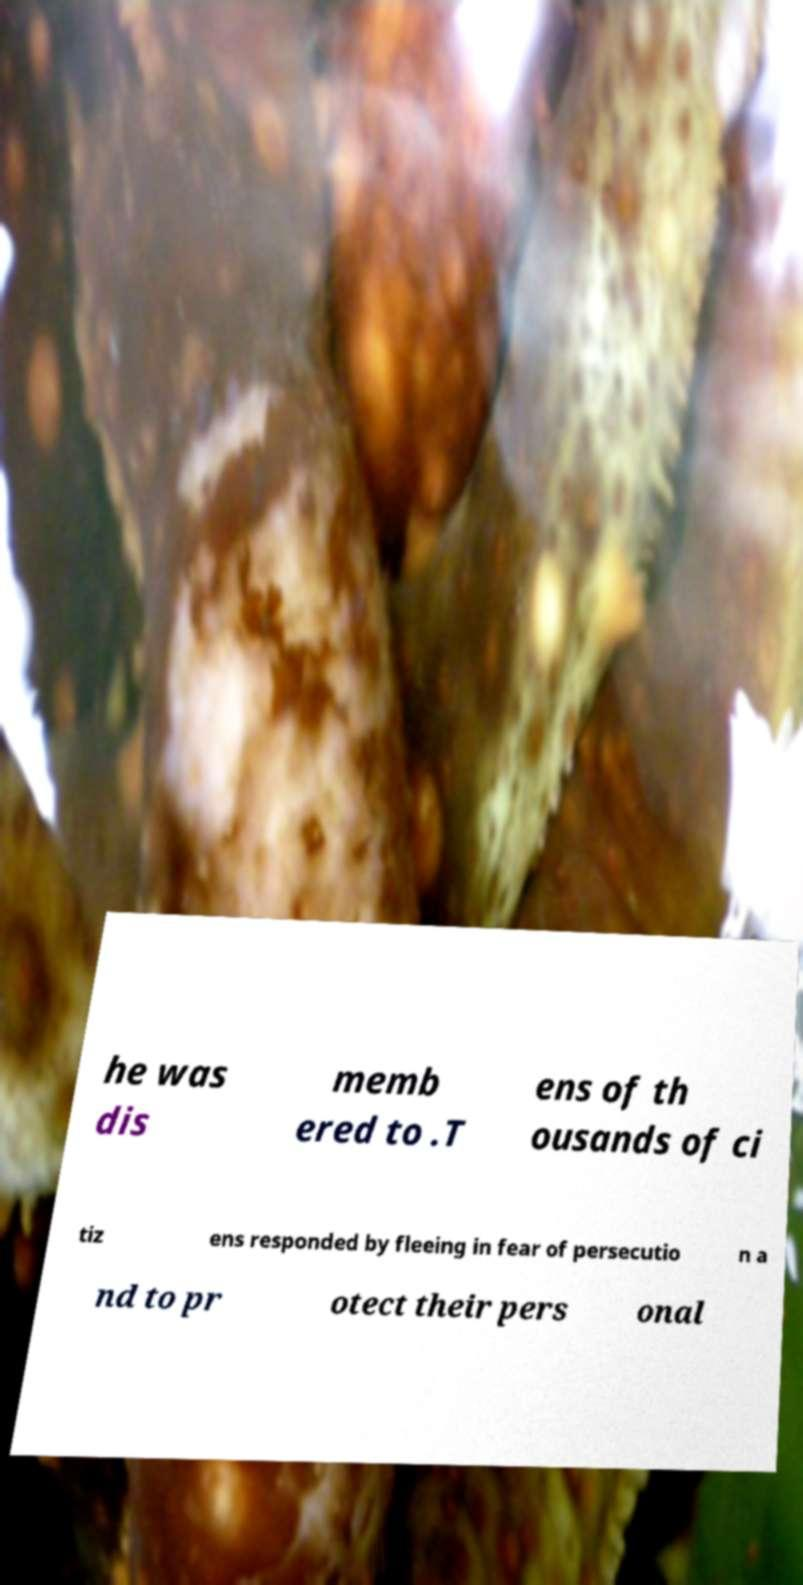Could you extract and type out the text from this image? he was dis memb ered to .T ens of th ousands of ci tiz ens responded by fleeing in fear of persecutio n a nd to pr otect their pers onal 